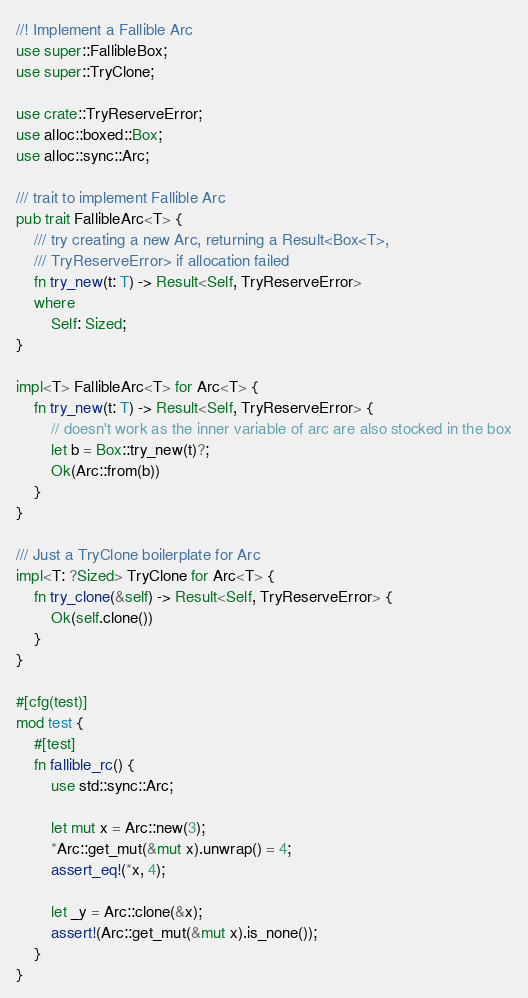<code> <loc_0><loc_0><loc_500><loc_500><_Rust_>//! Implement a Fallible Arc
use super::FallibleBox;
use super::TryClone;

use crate::TryReserveError;
use alloc::boxed::Box;
use alloc::sync::Arc;

/// trait to implement Fallible Arc
pub trait FallibleArc<T> {
    /// try creating a new Arc, returning a Result<Box<T>,
    /// TryReserveError> if allocation failed
    fn try_new(t: T) -> Result<Self, TryReserveError>
    where
        Self: Sized;
}

impl<T> FallibleArc<T> for Arc<T> {
    fn try_new(t: T) -> Result<Self, TryReserveError> {
        // doesn't work as the inner variable of arc are also stocked in the box
        let b = Box::try_new(t)?;
        Ok(Arc::from(b))
    }
}

/// Just a TryClone boilerplate for Arc
impl<T: ?Sized> TryClone for Arc<T> {
    fn try_clone(&self) -> Result<Self, TryReserveError> {
        Ok(self.clone())
    }
}

#[cfg(test)]
mod test {
    #[test]
    fn fallible_rc() {
        use std::sync::Arc;

        let mut x = Arc::new(3);
        *Arc::get_mut(&mut x).unwrap() = 4;
        assert_eq!(*x, 4);

        let _y = Arc::clone(&x);
        assert!(Arc::get_mut(&mut x).is_none());
    }
}
</code> 